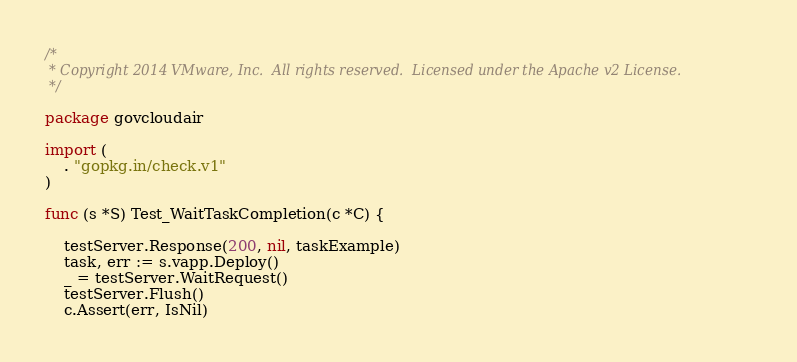Convert code to text. <code><loc_0><loc_0><loc_500><loc_500><_Go_>/*
 * Copyright 2014 VMware, Inc.  All rights reserved.  Licensed under the Apache v2 License.
 */

package govcloudair

import (
	. "gopkg.in/check.v1"
)

func (s *S) Test_WaitTaskCompletion(c *C) {

	testServer.Response(200, nil, taskExample)
	task, err := s.vapp.Deploy()
	_ = testServer.WaitRequest()
	testServer.Flush()
	c.Assert(err, IsNil)
</code> 